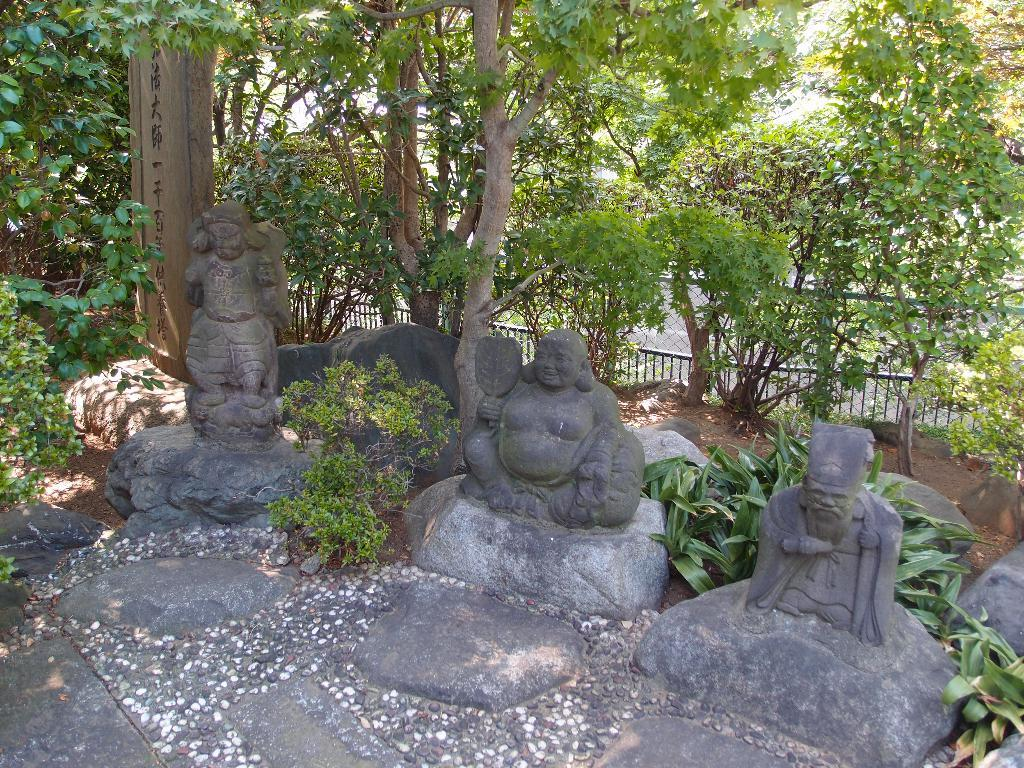What type of structures are present in the image? There are rock sculptures in the image. What type of vegetation can be seen in the image? There are trees in the image. What is located at the back of the image? There is a fence at the back in the image. How many trucks are parked near the rock sculptures in the image? There are no trucks present in the image; it only features rock sculptures, trees, and a fence. What type of jelly can be seen on the rock sculptures in the image? There is no jelly present on the rock sculptures in the image. 